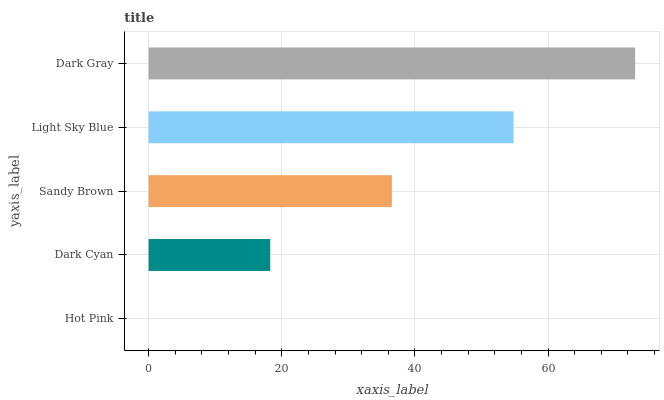Is Hot Pink the minimum?
Answer yes or no. Yes. Is Dark Gray the maximum?
Answer yes or no. Yes. Is Dark Cyan the minimum?
Answer yes or no. No. Is Dark Cyan the maximum?
Answer yes or no. No. Is Dark Cyan greater than Hot Pink?
Answer yes or no. Yes. Is Hot Pink less than Dark Cyan?
Answer yes or no. Yes. Is Hot Pink greater than Dark Cyan?
Answer yes or no. No. Is Dark Cyan less than Hot Pink?
Answer yes or no. No. Is Sandy Brown the high median?
Answer yes or no. Yes. Is Sandy Brown the low median?
Answer yes or no. Yes. Is Dark Cyan the high median?
Answer yes or no. No. Is Dark Gray the low median?
Answer yes or no. No. 